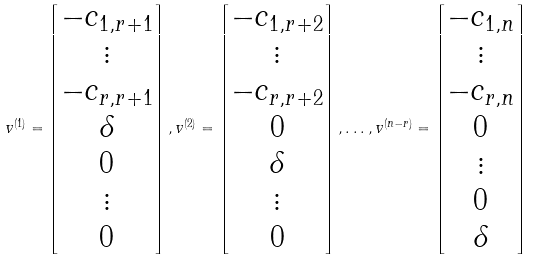Convert formula to latex. <formula><loc_0><loc_0><loc_500><loc_500>v ^ { ( 1 ) } = \begin{bmatrix} - c _ { 1 , r + 1 } \\ \vdots \\ - c _ { r , r + 1 } \\ \delta \\ 0 \\ \vdots \\ 0 \end{bmatrix} , v ^ { ( 2 ) } = \begin{bmatrix} - c _ { 1 , r + 2 } \\ \vdots \\ - c _ { r , r + 2 } \\ 0 \\ \delta \\ \vdots \\ 0 \end{bmatrix} , \dots , v ^ { ( n - r ) } = \begin{bmatrix} - c _ { 1 , n } \\ \vdots \\ - c _ { r , n } \\ 0 \\ \vdots \\ 0 \\ \delta \end{bmatrix}</formula> 